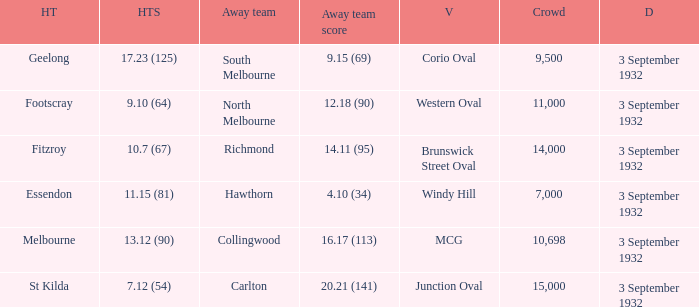What is the total Crowd number for the team that has an Away team score of 12.18 (90)? 11000.0. 